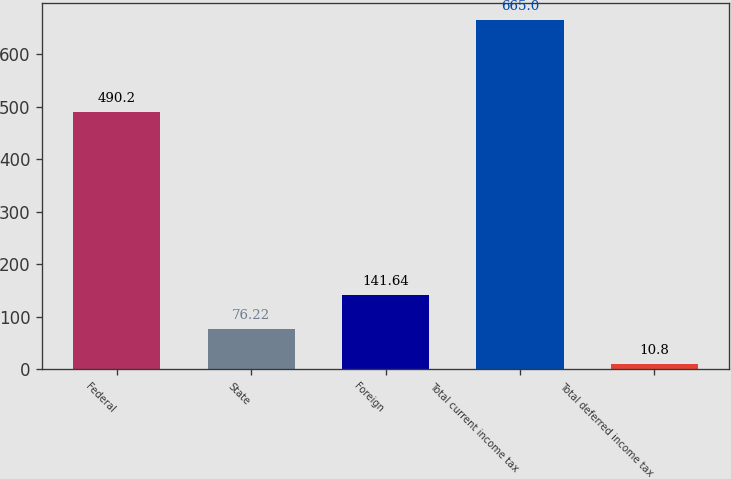Convert chart to OTSL. <chart><loc_0><loc_0><loc_500><loc_500><bar_chart><fcel>Federal<fcel>State<fcel>Foreign<fcel>Total current income tax<fcel>Total deferred income tax<nl><fcel>490.2<fcel>76.22<fcel>141.64<fcel>665<fcel>10.8<nl></chart> 